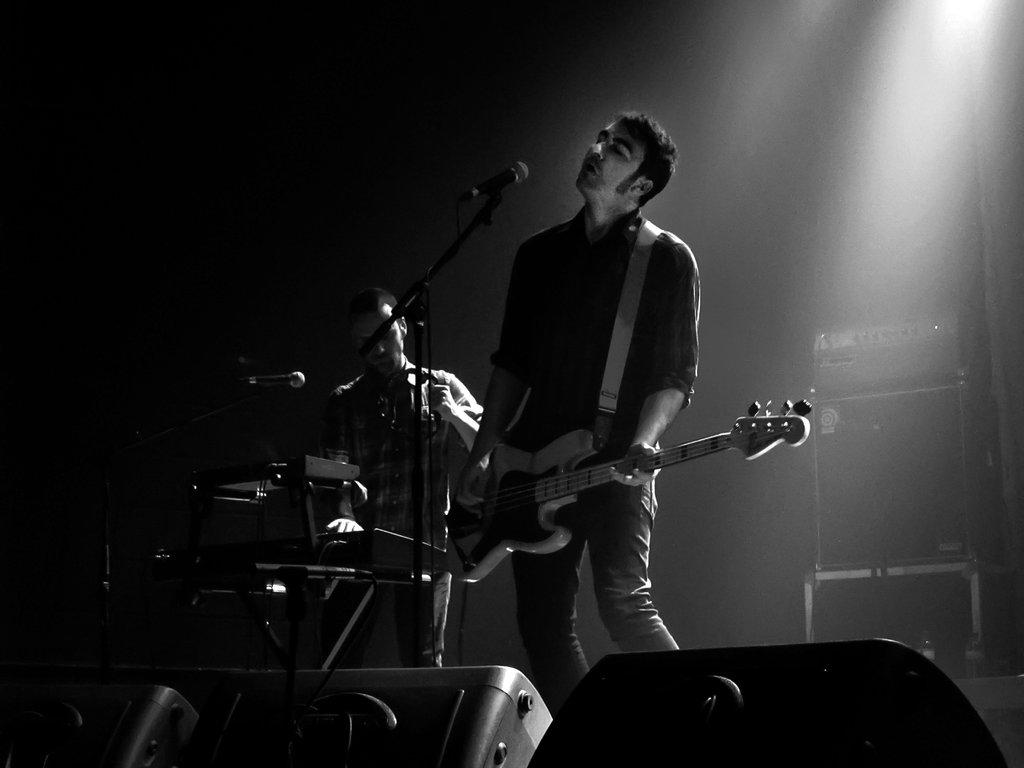What is the color scheme of the image? The image is black and white. What is the man in the image doing? The man is playing guitar in the image. Where is the man playing guitar? The man is playing in front of a microphone. What other musical instrument is present in the image? There is a piano in the image. Is the man playing both instruments simultaneously? Yes, the man is also playing the piano in the image. What type of quartz can be seen in the image? There is no quartz present in the image. How does the man shake the kettle while playing the guitar? There is no kettle present in the image, and the man is not shaking anything while playing the guitar. 